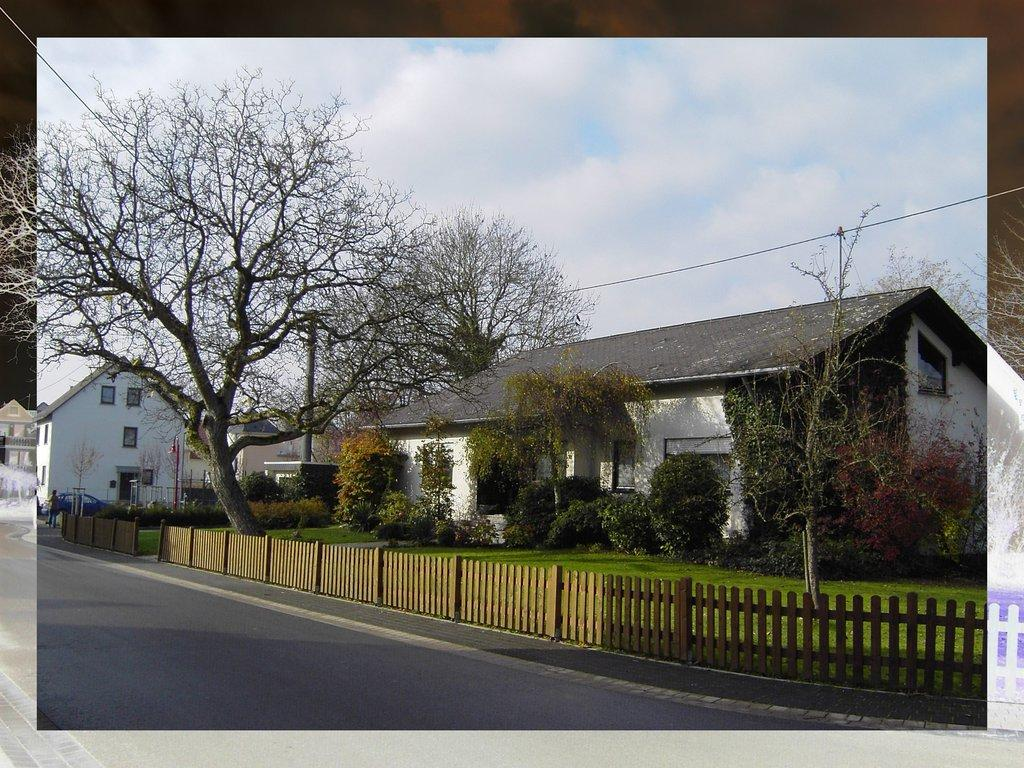What is located in the foreground of the image? There is a road and a railing in the foreground of the image. What can be seen in the background of the image? There are plants, trees, houses, a pole, a cable, and the sky visible in the background of the image. What is the condition of the sky in the image? The sky is visible in the background of the image, and there are clouds present. What rhythm is being played by the idea in the image? There is no idea or rhythm present in the image. How many quarters can be seen on the pole in the image? There is no pole with quarters in the image; it only features a pole with a cable. 